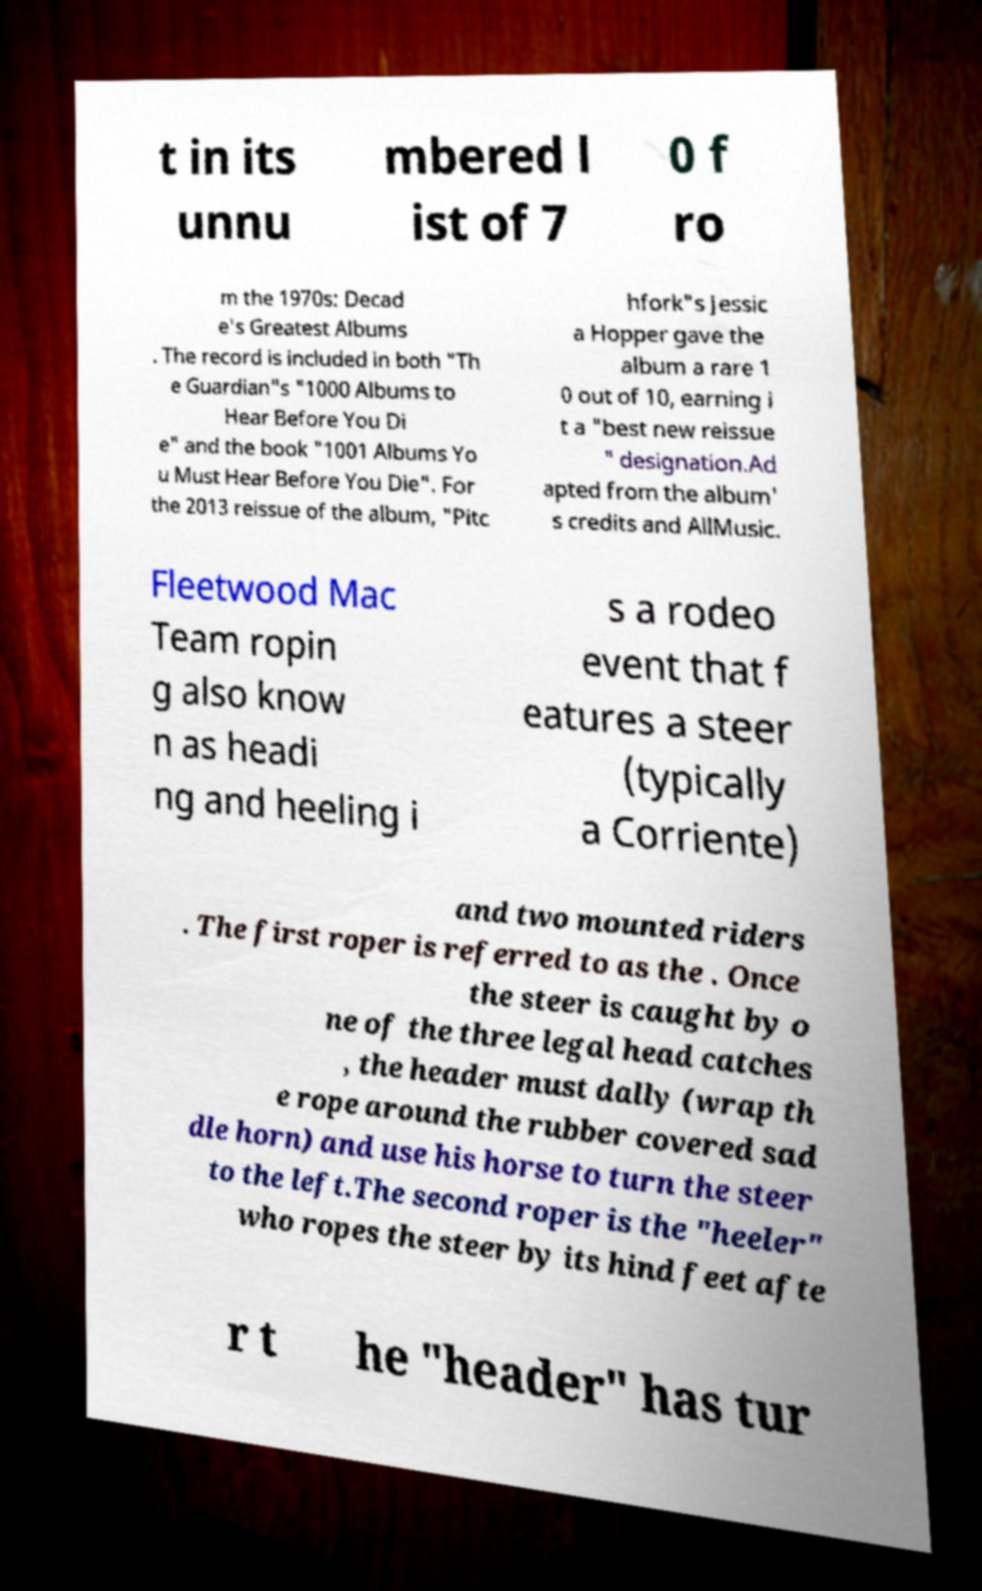What messages or text are displayed in this image? I need them in a readable, typed format. t in its unnu mbered l ist of 7 0 f ro m the 1970s: Decad e's Greatest Albums . The record is included in both "Th e Guardian"s "1000 Albums to Hear Before You Di e" and the book "1001 Albums Yo u Must Hear Before You Die". For the 2013 reissue of the album, "Pitc hfork"s Jessic a Hopper gave the album a rare 1 0 out of 10, earning i t a "best new reissue " designation.Ad apted from the album' s credits and AllMusic. Fleetwood Mac Team ropin g also know n as headi ng and heeling i s a rodeo event that f eatures a steer (typically a Corriente) and two mounted riders . The first roper is referred to as the . Once the steer is caught by o ne of the three legal head catches , the header must dally (wrap th e rope around the rubber covered sad dle horn) and use his horse to turn the steer to the left.The second roper is the "heeler" who ropes the steer by its hind feet afte r t he "header" has tur 